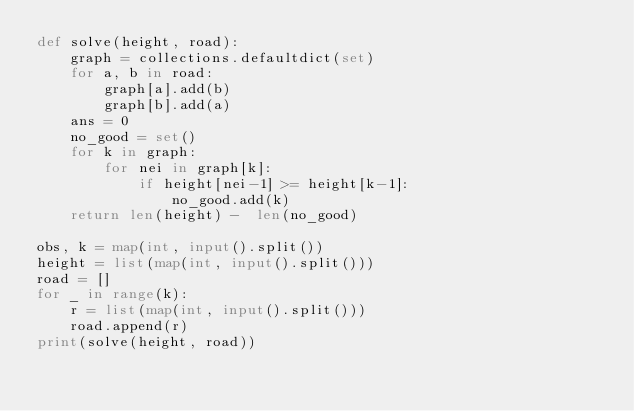<code> <loc_0><loc_0><loc_500><loc_500><_Python_>def solve(height, road):
    graph = collections.defaultdict(set)
    for a, b in road:
        graph[a].add(b)
        graph[b].add(a)
    ans = 0
    no_good = set()
    for k in graph:
        for nei in graph[k]:
            if height[nei-1] >= height[k-1]:
                no_good.add(k)
    return len(height) -  len(no_good)

obs, k = map(int, input().split())
height = list(map(int, input().split()))
road = []
for _ in range(k):
    r = list(map(int, input().split()))
    road.append(r)
print(solve(height, road))
</code> 